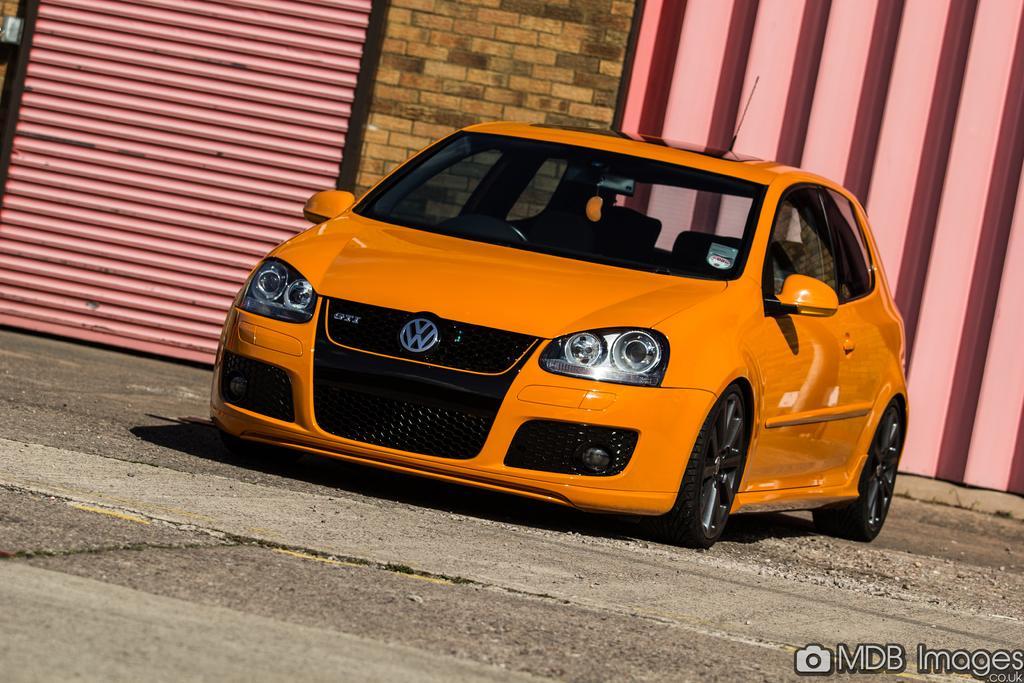Describe this image in one or two sentences. In this picture we can see a car. There is a shutter and a wall in the background. 